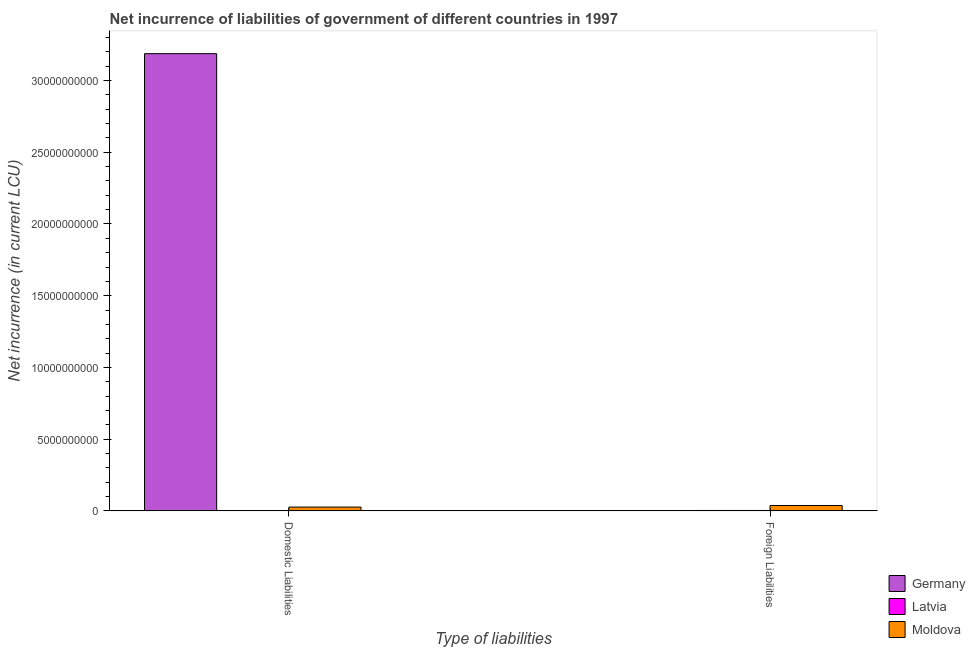How many groups of bars are there?
Provide a succinct answer. 2. Are the number of bars per tick equal to the number of legend labels?
Provide a short and direct response. No. Are the number of bars on each tick of the X-axis equal?
Give a very brief answer. Yes. How many bars are there on the 1st tick from the left?
Offer a very short reply. 2. How many bars are there on the 1st tick from the right?
Keep it short and to the point. 2. What is the label of the 2nd group of bars from the left?
Provide a short and direct response. Foreign Liabilities. What is the net incurrence of domestic liabilities in Moldova?
Provide a short and direct response. 2.66e+08. Across all countries, what is the maximum net incurrence of foreign liabilities?
Offer a very short reply. 3.76e+08. Across all countries, what is the minimum net incurrence of domestic liabilities?
Your response must be concise. 0. In which country was the net incurrence of foreign liabilities maximum?
Keep it short and to the point. Moldova. What is the total net incurrence of foreign liabilities in the graph?
Your answer should be compact. 4.05e+08. What is the difference between the net incurrence of foreign liabilities in Moldova and that in Latvia?
Ensure brevity in your answer.  3.48e+08. What is the difference between the net incurrence of foreign liabilities in Germany and the net incurrence of domestic liabilities in Moldova?
Your answer should be very brief. -2.66e+08. What is the average net incurrence of foreign liabilities per country?
Offer a terse response. 1.35e+08. What is the difference between the net incurrence of domestic liabilities and net incurrence of foreign liabilities in Moldova?
Your answer should be very brief. -1.10e+08. Is the net incurrence of domestic liabilities in Moldova less than that in Germany?
Your answer should be very brief. Yes. How many countries are there in the graph?
Keep it short and to the point. 3. Does the graph contain grids?
Your answer should be compact. No. Where does the legend appear in the graph?
Your answer should be very brief. Bottom right. How are the legend labels stacked?
Provide a short and direct response. Vertical. What is the title of the graph?
Provide a short and direct response. Net incurrence of liabilities of government of different countries in 1997. What is the label or title of the X-axis?
Give a very brief answer. Type of liabilities. What is the label or title of the Y-axis?
Provide a short and direct response. Net incurrence (in current LCU). What is the Net incurrence (in current LCU) of Germany in Domestic Liabilities?
Make the answer very short. 3.19e+1. What is the Net incurrence (in current LCU) of Moldova in Domestic Liabilities?
Your answer should be compact. 2.66e+08. What is the Net incurrence (in current LCU) in Germany in Foreign Liabilities?
Provide a succinct answer. 0. What is the Net incurrence (in current LCU) of Latvia in Foreign Liabilities?
Make the answer very short. 2.86e+07. What is the Net incurrence (in current LCU) in Moldova in Foreign Liabilities?
Offer a very short reply. 3.76e+08. Across all Type of liabilities, what is the maximum Net incurrence (in current LCU) of Germany?
Offer a terse response. 3.19e+1. Across all Type of liabilities, what is the maximum Net incurrence (in current LCU) of Latvia?
Provide a short and direct response. 2.86e+07. Across all Type of liabilities, what is the maximum Net incurrence (in current LCU) of Moldova?
Your response must be concise. 3.76e+08. Across all Type of liabilities, what is the minimum Net incurrence (in current LCU) of Germany?
Keep it short and to the point. 0. Across all Type of liabilities, what is the minimum Net incurrence (in current LCU) of Moldova?
Give a very brief answer. 2.66e+08. What is the total Net incurrence (in current LCU) of Germany in the graph?
Give a very brief answer. 3.19e+1. What is the total Net incurrence (in current LCU) of Latvia in the graph?
Your response must be concise. 2.86e+07. What is the total Net incurrence (in current LCU) in Moldova in the graph?
Provide a succinct answer. 6.42e+08. What is the difference between the Net incurrence (in current LCU) in Moldova in Domestic Liabilities and that in Foreign Liabilities?
Keep it short and to the point. -1.10e+08. What is the difference between the Net incurrence (in current LCU) in Germany in Domestic Liabilities and the Net incurrence (in current LCU) in Latvia in Foreign Liabilities?
Provide a short and direct response. 3.18e+1. What is the difference between the Net incurrence (in current LCU) of Germany in Domestic Liabilities and the Net incurrence (in current LCU) of Moldova in Foreign Liabilities?
Your answer should be compact. 3.15e+1. What is the average Net incurrence (in current LCU) of Germany per Type of liabilities?
Offer a terse response. 1.59e+1. What is the average Net incurrence (in current LCU) of Latvia per Type of liabilities?
Ensure brevity in your answer.  1.43e+07. What is the average Net incurrence (in current LCU) in Moldova per Type of liabilities?
Make the answer very short. 3.21e+08. What is the difference between the Net incurrence (in current LCU) in Germany and Net incurrence (in current LCU) in Moldova in Domestic Liabilities?
Keep it short and to the point. 3.16e+1. What is the difference between the Net incurrence (in current LCU) of Latvia and Net incurrence (in current LCU) of Moldova in Foreign Liabilities?
Your answer should be compact. -3.48e+08. What is the ratio of the Net incurrence (in current LCU) of Moldova in Domestic Liabilities to that in Foreign Liabilities?
Offer a very short reply. 0.71. What is the difference between the highest and the second highest Net incurrence (in current LCU) in Moldova?
Your response must be concise. 1.10e+08. What is the difference between the highest and the lowest Net incurrence (in current LCU) in Germany?
Ensure brevity in your answer.  3.19e+1. What is the difference between the highest and the lowest Net incurrence (in current LCU) in Latvia?
Give a very brief answer. 2.86e+07. What is the difference between the highest and the lowest Net incurrence (in current LCU) of Moldova?
Your answer should be very brief. 1.10e+08. 